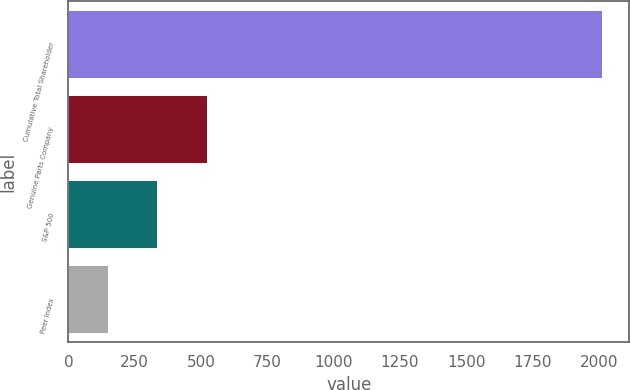Convert chart to OTSL. <chart><loc_0><loc_0><loc_500><loc_500><bar_chart><fcel>Cumulative Total Shareholder<fcel>Genuine Parts Company<fcel>S&P 500<fcel>Peer Index<nl><fcel>2014<fcel>521.66<fcel>335.12<fcel>148.58<nl></chart> 